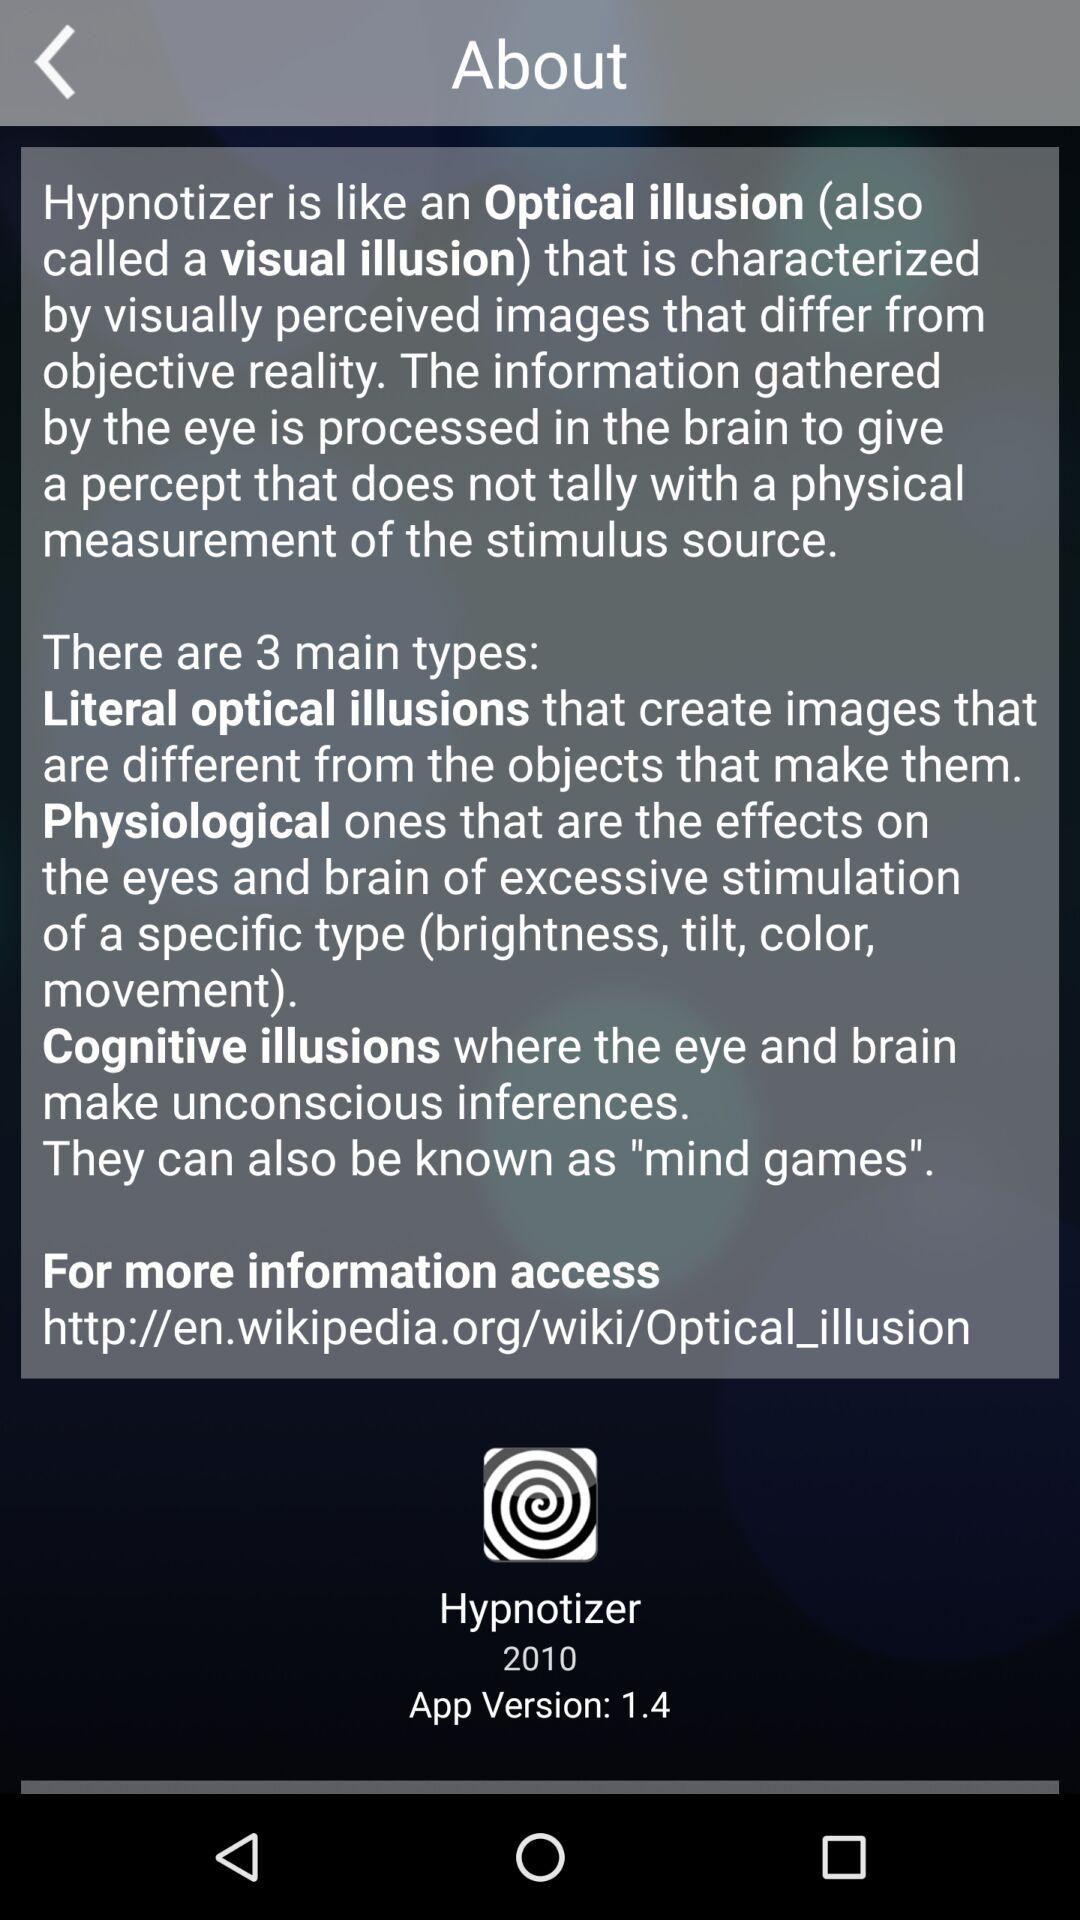What year is mentioned? The mentioned year is 2010. 